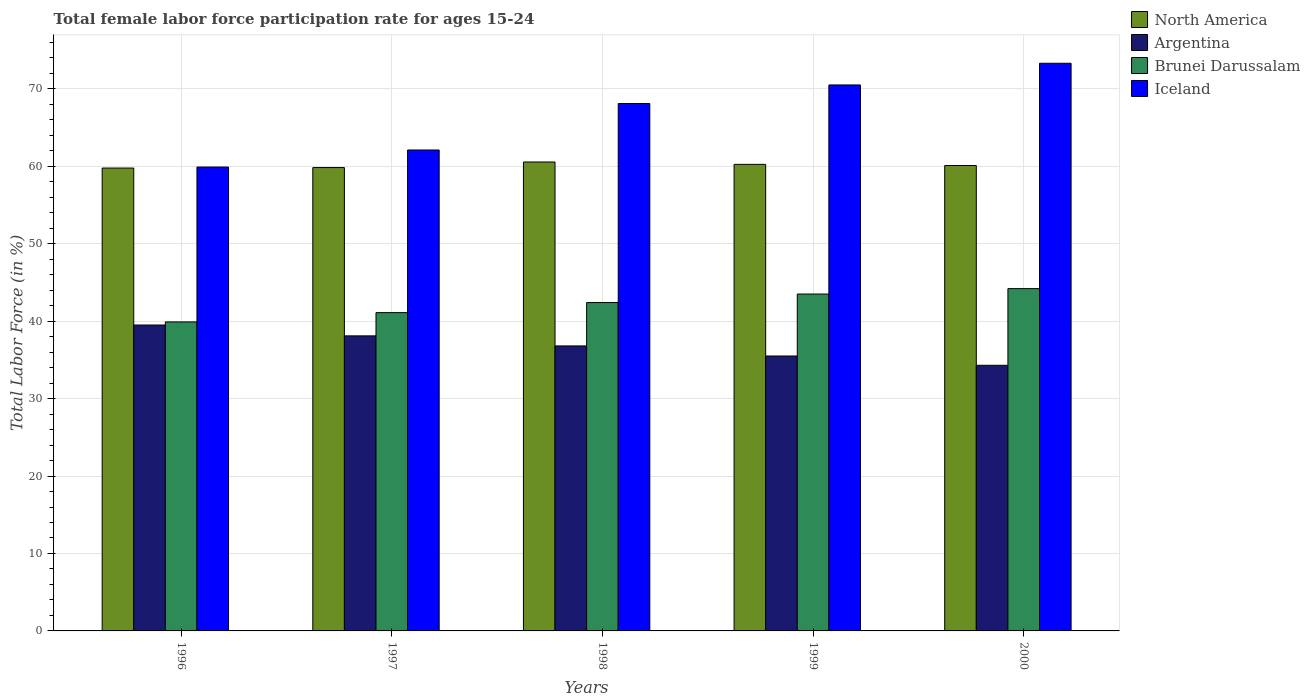How many different coloured bars are there?
Give a very brief answer. 4. How many groups of bars are there?
Make the answer very short. 5. Are the number of bars per tick equal to the number of legend labels?
Your response must be concise. Yes. Are the number of bars on each tick of the X-axis equal?
Your response must be concise. Yes. What is the label of the 2nd group of bars from the left?
Offer a terse response. 1997. In how many cases, is the number of bars for a given year not equal to the number of legend labels?
Offer a terse response. 0. What is the female labor force participation rate in Iceland in 1999?
Give a very brief answer. 70.5. Across all years, what is the maximum female labor force participation rate in Iceland?
Keep it short and to the point. 73.3. Across all years, what is the minimum female labor force participation rate in Iceland?
Make the answer very short. 59.9. In which year was the female labor force participation rate in Brunei Darussalam minimum?
Offer a very short reply. 1996. What is the total female labor force participation rate in North America in the graph?
Give a very brief answer. 300.49. What is the difference between the female labor force participation rate in Iceland in 1997 and that in 1999?
Ensure brevity in your answer.  -8.4. What is the difference between the female labor force participation rate in North America in 1998 and the female labor force participation rate in Argentina in 1996?
Keep it short and to the point. 21.05. What is the average female labor force participation rate in North America per year?
Your response must be concise. 60.1. In the year 2000, what is the difference between the female labor force participation rate in Brunei Darussalam and female labor force participation rate in Argentina?
Offer a very short reply. 9.9. What is the ratio of the female labor force participation rate in Argentina in 1996 to that in 1999?
Provide a short and direct response. 1.11. What is the difference between the highest and the second highest female labor force participation rate in Argentina?
Offer a very short reply. 1.4. What is the difference between the highest and the lowest female labor force participation rate in Brunei Darussalam?
Keep it short and to the point. 4.3. Is the sum of the female labor force participation rate in North America in 1996 and 1998 greater than the maximum female labor force participation rate in Iceland across all years?
Give a very brief answer. Yes. Is it the case that in every year, the sum of the female labor force participation rate in North America and female labor force participation rate in Iceland is greater than the sum of female labor force participation rate in Brunei Darussalam and female labor force participation rate in Argentina?
Provide a succinct answer. Yes. What does the 1st bar from the right in 1999 represents?
Make the answer very short. Iceland. Does the graph contain any zero values?
Your answer should be very brief. No. Where does the legend appear in the graph?
Ensure brevity in your answer.  Top right. What is the title of the graph?
Provide a succinct answer. Total female labor force participation rate for ages 15-24. What is the label or title of the X-axis?
Your answer should be compact. Years. What is the label or title of the Y-axis?
Ensure brevity in your answer.  Total Labor Force (in %). What is the Total Labor Force (in %) in North America in 1996?
Your answer should be compact. 59.77. What is the Total Labor Force (in %) of Argentina in 1996?
Your answer should be very brief. 39.5. What is the Total Labor Force (in %) in Brunei Darussalam in 1996?
Make the answer very short. 39.9. What is the Total Labor Force (in %) in Iceland in 1996?
Ensure brevity in your answer.  59.9. What is the Total Labor Force (in %) in North America in 1997?
Your response must be concise. 59.83. What is the Total Labor Force (in %) of Argentina in 1997?
Offer a terse response. 38.1. What is the Total Labor Force (in %) of Brunei Darussalam in 1997?
Make the answer very short. 41.1. What is the Total Labor Force (in %) of Iceland in 1997?
Your answer should be very brief. 62.1. What is the Total Labor Force (in %) of North America in 1998?
Give a very brief answer. 60.55. What is the Total Labor Force (in %) in Argentina in 1998?
Keep it short and to the point. 36.8. What is the Total Labor Force (in %) of Brunei Darussalam in 1998?
Provide a short and direct response. 42.4. What is the Total Labor Force (in %) of Iceland in 1998?
Provide a succinct answer. 68.1. What is the Total Labor Force (in %) in North America in 1999?
Offer a very short reply. 60.24. What is the Total Labor Force (in %) of Argentina in 1999?
Ensure brevity in your answer.  35.5. What is the Total Labor Force (in %) in Brunei Darussalam in 1999?
Your answer should be very brief. 43.5. What is the Total Labor Force (in %) in Iceland in 1999?
Provide a short and direct response. 70.5. What is the Total Labor Force (in %) in North America in 2000?
Provide a succinct answer. 60.1. What is the Total Labor Force (in %) in Argentina in 2000?
Give a very brief answer. 34.3. What is the Total Labor Force (in %) in Brunei Darussalam in 2000?
Offer a very short reply. 44.2. What is the Total Labor Force (in %) of Iceland in 2000?
Your answer should be compact. 73.3. Across all years, what is the maximum Total Labor Force (in %) of North America?
Keep it short and to the point. 60.55. Across all years, what is the maximum Total Labor Force (in %) of Argentina?
Provide a short and direct response. 39.5. Across all years, what is the maximum Total Labor Force (in %) of Brunei Darussalam?
Your response must be concise. 44.2. Across all years, what is the maximum Total Labor Force (in %) of Iceland?
Give a very brief answer. 73.3. Across all years, what is the minimum Total Labor Force (in %) in North America?
Keep it short and to the point. 59.77. Across all years, what is the minimum Total Labor Force (in %) in Argentina?
Offer a terse response. 34.3. Across all years, what is the minimum Total Labor Force (in %) of Brunei Darussalam?
Your answer should be compact. 39.9. Across all years, what is the minimum Total Labor Force (in %) of Iceland?
Your answer should be compact. 59.9. What is the total Total Labor Force (in %) of North America in the graph?
Offer a very short reply. 300.49. What is the total Total Labor Force (in %) of Argentina in the graph?
Your response must be concise. 184.2. What is the total Total Labor Force (in %) of Brunei Darussalam in the graph?
Offer a terse response. 211.1. What is the total Total Labor Force (in %) of Iceland in the graph?
Make the answer very short. 333.9. What is the difference between the Total Labor Force (in %) of North America in 1996 and that in 1997?
Provide a succinct answer. -0.06. What is the difference between the Total Labor Force (in %) in Argentina in 1996 and that in 1997?
Your response must be concise. 1.4. What is the difference between the Total Labor Force (in %) in Brunei Darussalam in 1996 and that in 1997?
Your answer should be compact. -1.2. What is the difference between the Total Labor Force (in %) of Iceland in 1996 and that in 1997?
Your answer should be very brief. -2.2. What is the difference between the Total Labor Force (in %) of North America in 1996 and that in 1998?
Provide a short and direct response. -0.78. What is the difference between the Total Labor Force (in %) of Brunei Darussalam in 1996 and that in 1998?
Your answer should be compact. -2.5. What is the difference between the Total Labor Force (in %) of Iceland in 1996 and that in 1998?
Your answer should be compact. -8.2. What is the difference between the Total Labor Force (in %) in North America in 1996 and that in 1999?
Keep it short and to the point. -0.48. What is the difference between the Total Labor Force (in %) in Argentina in 1996 and that in 1999?
Your answer should be compact. 4. What is the difference between the Total Labor Force (in %) in Brunei Darussalam in 1996 and that in 1999?
Your answer should be compact. -3.6. What is the difference between the Total Labor Force (in %) of North America in 1996 and that in 2000?
Provide a succinct answer. -0.33. What is the difference between the Total Labor Force (in %) of Argentina in 1996 and that in 2000?
Provide a short and direct response. 5.2. What is the difference between the Total Labor Force (in %) of Iceland in 1996 and that in 2000?
Offer a very short reply. -13.4. What is the difference between the Total Labor Force (in %) of North America in 1997 and that in 1998?
Provide a succinct answer. -0.72. What is the difference between the Total Labor Force (in %) of Argentina in 1997 and that in 1998?
Your response must be concise. 1.3. What is the difference between the Total Labor Force (in %) in North America in 1997 and that in 1999?
Your answer should be very brief. -0.41. What is the difference between the Total Labor Force (in %) of Brunei Darussalam in 1997 and that in 1999?
Your response must be concise. -2.4. What is the difference between the Total Labor Force (in %) in Iceland in 1997 and that in 1999?
Make the answer very short. -8.4. What is the difference between the Total Labor Force (in %) of North America in 1997 and that in 2000?
Provide a short and direct response. -0.26. What is the difference between the Total Labor Force (in %) of North America in 1998 and that in 1999?
Your answer should be very brief. 0.31. What is the difference between the Total Labor Force (in %) of Iceland in 1998 and that in 1999?
Your answer should be compact. -2.4. What is the difference between the Total Labor Force (in %) in North America in 1998 and that in 2000?
Offer a terse response. 0.45. What is the difference between the Total Labor Force (in %) in Argentina in 1998 and that in 2000?
Keep it short and to the point. 2.5. What is the difference between the Total Labor Force (in %) in Iceland in 1998 and that in 2000?
Give a very brief answer. -5.2. What is the difference between the Total Labor Force (in %) in North America in 1999 and that in 2000?
Provide a succinct answer. 0.15. What is the difference between the Total Labor Force (in %) in Brunei Darussalam in 1999 and that in 2000?
Make the answer very short. -0.7. What is the difference between the Total Labor Force (in %) in Iceland in 1999 and that in 2000?
Keep it short and to the point. -2.8. What is the difference between the Total Labor Force (in %) in North America in 1996 and the Total Labor Force (in %) in Argentina in 1997?
Your answer should be compact. 21.67. What is the difference between the Total Labor Force (in %) of North America in 1996 and the Total Labor Force (in %) of Brunei Darussalam in 1997?
Ensure brevity in your answer.  18.67. What is the difference between the Total Labor Force (in %) of North America in 1996 and the Total Labor Force (in %) of Iceland in 1997?
Your answer should be very brief. -2.33. What is the difference between the Total Labor Force (in %) of Argentina in 1996 and the Total Labor Force (in %) of Brunei Darussalam in 1997?
Ensure brevity in your answer.  -1.6. What is the difference between the Total Labor Force (in %) in Argentina in 1996 and the Total Labor Force (in %) in Iceland in 1997?
Give a very brief answer. -22.6. What is the difference between the Total Labor Force (in %) in Brunei Darussalam in 1996 and the Total Labor Force (in %) in Iceland in 1997?
Provide a short and direct response. -22.2. What is the difference between the Total Labor Force (in %) of North America in 1996 and the Total Labor Force (in %) of Argentina in 1998?
Offer a very short reply. 22.97. What is the difference between the Total Labor Force (in %) in North America in 1996 and the Total Labor Force (in %) in Brunei Darussalam in 1998?
Keep it short and to the point. 17.37. What is the difference between the Total Labor Force (in %) in North America in 1996 and the Total Labor Force (in %) in Iceland in 1998?
Ensure brevity in your answer.  -8.33. What is the difference between the Total Labor Force (in %) in Argentina in 1996 and the Total Labor Force (in %) in Iceland in 1998?
Provide a succinct answer. -28.6. What is the difference between the Total Labor Force (in %) in Brunei Darussalam in 1996 and the Total Labor Force (in %) in Iceland in 1998?
Your response must be concise. -28.2. What is the difference between the Total Labor Force (in %) in North America in 1996 and the Total Labor Force (in %) in Argentina in 1999?
Your response must be concise. 24.27. What is the difference between the Total Labor Force (in %) in North America in 1996 and the Total Labor Force (in %) in Brunei Darussalam in 1999?
Offer a terse response. 16.27. What is the difference between the Total Labor Force (in %) of North America in 1996 and the Total Labor Force (in %) of Iceland in 1999?
Your response must be concise. -10.73. What is the difference between the Total Labor Force (in %) of Argentina in 1996 and the Total Labor Force (in %) of Brunei Darussalam in 1999?
Offer a terse response. -4. What is the difference between the Total Labor Force (in %) in Argentina in 1996 and the Total Labor Force (in %) in Iceland in 1999?
Keep it short and to the point. -31. What is the difference between the Total Labor Force (in %) of Brunei Darussalam in 1996 and the Total Labor Force (in %) of Iceland in 1999?
Offer a terse response. -30.6. What is the difference between the Total Labor Force (in %) of North America in 1996 and the Total Labor Force (in %) of Argentina in 2000?
Offer a terse response. 25.47. What is the difference between the Total Labor Force (in %) in North America in 1996 and the Total Labor Force (in %) in Brunei Darussalam in 2000?
Your answer should be compact. 15.57. What is the difference between the Total Labor Force (in %) of North America in 1996 and the Total Labor Force (in %) of Iceland in 2000?
Offer a very short reply. -13.53. What is the difference between the Total Labor Force (in %) of Argentina in 1996 and the Total Labor Force (in %) of Brunei Darussalam in 2000?
Ensure brevity in your answer.  -4.7. What is the difference between the Total Labor Force (in %) in Argentina in 1996 and the Total Labor Force (in %) in Iceland in 2000?
Give a very brief answer. -33.8. What is the difference between the Total Labor Force (in %) of Brunei Darussalam in 1996 and the Total Labor Force (in %) of Iceland in 2000?
Provide a succinct answer. -33.4. What is the difference between the Total Labor Force (in %) of North America in 1997 and the Total Labor Force (in %) of Argentina in 1998?
Give a very brief answer. 23.03. What is the difference between the Total Labor Force (in %) in North America in 1997 and the Total Labor Force (in %) in Brunei Darussalam in 1998?
Make the answer very short. 17.43. What is the difference between the Total Labor Force (in %) in North America in 1997 and the Total Labor Force (in %) in Iceland in 1998?
Your answer should be compact. -8.27. What is the difference between the Total Labor Force (in %) of Brunei Darussalam in 1997 and the Total Labor Force (in %) of Iceland in 1998?
Offer a terse response. -27. What is the difference between the Total Labor Force (in %) in North America in 1997 and the Total Labor Force (in %) in Argentina in 1999?
Keep it short and to the point. 24.33. What is the difference between the Total Labor Force (in %) of North America in 1997 and the Total Labor Force (in %) of Brunei Darussalam in 1999?
Provide a succinct answer. 16.33. What is the difference between the Total Labor Force (in %) of North America in 1997 and the Total Labor Force (in %) of Iceland in 1999?
Offer a very short reply. -10.67. What is the difference between the Total Labor Force (in %) in Argentina in 1997 and the Total Labor Force (in %) in Iceland in 1999?
Keep it short and to the point. -32.4. What is the difference between the Total Labor Force (in %) of Brunei Darussalam in 1997 and the Total Labor Force (in %) of Iceland in 1999?
Provide a succinct answer. -29.4. What is the difference between the Total Labor Force (in %) in North America in 1997 and the Total Labor Force (in %) in Argentina in 2000?
Give a very brief answer. 25.53. What is the difference between the Total Labor Force (in %) of North America in 1997 and the Total Labor Force (in %) of Brunei Darussalam in 2000?
Keep it short and to the point. 15.63. What is the difference between the Total Labor Force (in %) of North America in 1997 and the Total Labor Force (in %) of Iceland in 2000?
Provide a succinct answer. -13.47. What is the difference between the Total Labor Force (in %) in Argentina in 1997 and the Total Labor Force (in %) in Brunei Darussalam in 2000?
Offer a terse response. -6.1. What is the difference between the Total Labor Force (in %) of Argentina in 1997 and the Total Labor Force (in %) of Iceland in 2000?
Provide a short and direct response. -35.2. What is the difference between the Total Labor Force (in %) of Brunei Darussalam in 1997 and the Total Labor Force (in %) of Iceland in 2000?
Keep it short and to the point. -32.2. What is the difference between the Total Labor Force (in %) of North America in 1998 and the Total Labor Force (in %) of Argentina in 1999?
Offer a very short reply. 25.05. What is the difference between the Total Labor Force (in %) of North America in 1998 and the Total Labor Force (in %) of Brunei Darussalam in 1999?
Make the answer very short. 17.05. What is the difference between the Total Labor Force (in %) of North America in 1998 and the Total Labor Force (in %) of Iceland in 1999?
Provide a succinct answer. -9.95. What is the difference between the Total Labor Force (in %) in Argentina in 1998 and the Total Labor Force (in %) in Iceland in 1999?
Your answer should be very brief. -33.7. What is the difference between the Total Labor Force (in %) in Brunei Darussalam in 1998 and the Total Labor Force (in %) in Iceland in 1999?
Keep it short and to the point. -28.1. What is the difference between the Total Labor Force (in %) in North America in 1998 and the Total Labor Force (in %) in Argentina in 2000?
Your answer should be compact. 26.25. What is the difference between the Total Labor Force (in %) of North America in 1998 and the Total Labor Force (in %) of Brunei Darussalam in 2000?
Make the answer very short. 16.35. What is the difference between the Total Labor Force (in %) of North America in 1998 and the Total Labor Force (in %) of Iceland in 2000?
Your answer should be very brief. -12.75. What is the difference between the Total Labor Force (in %) of Argentina in 1998 and the Total Labor Force (in %) of Iceland in 2000?
Ensure brevity in your answer.  -36.5. What is the difference between the Total Labor Force (in %) of Brunei Darussalam in 1998 and the Total Labor Force (in %) of Iceland in 2000?
Provide a short and direct response. -30.9. What is the difference between the Total Labor Force (in %) of North America in 1999 and the Total Labor Force (in %) of Argentina in 2000?
Ensure brevity in your answer.  25.94. What is the difference between the Total Labor Force (in %) of North America in 1999 and the Total Labor Force (in %) of Brunei Darussalam in 2000?
Offer a terse response. 16.04. What is the difference between the Total Labor Force (in %) in North America in 1999 and the Total Labor Force (in %) in Iceland in 2000?
Provide a short and direct response. -13.06. What is the difference between the Total Labor Force (in %) of Argentina in 1999 and the Total Labor Force (in %) of Brunei Darussalam in 2000?
Ensure brevity in your answer.  -8.7. What is the difference between the Total Labor Force (in %) in Argentina in 1999 and the Total Labor Force (in %) in Iceland in 2000?
Offer a very short reply. -37.8. What is the difference between the Total Labor Force (in %) of Brunei Darussalam in 1999 and the Total Labor Force (in %) of Iceland in 2000?
Provide a succinct answer. -29.8. What is the average Total Labor Force (in %) in North America per year?
Ensure brevity in your answer.  60.1. What is the average Total Labor Force (in %) of Argentina per year?
Your answer should be compact. 36.84. What is the average Total Labor Force (in %) in Brunei Darussalam per year?
Your response must be concise. 42.22. What is the average Total Labor Force (in %) of Iceland per year?
Your answer should be very brief. 66.78. In the year 1996, what is the difference between the Total Labor Force (in %) in North America and Total Labor Force (in %) in Argentina?
Give a very brief answer. 20.27. In the year 1996, what is the difference between the Total Labor Force (in %) of North America and Total Labor Force (in %) of Brunei Darussalam?
Your answer should be compact. 19.87. In the year 1996, what is the difference between the Total Labor Force (in %) of North America and Total Labor Force (in %) of Iceland?
Provide a succinct answer. -0.13. In the year 1996, what is the difference between the Total Labor Force (in %) in Argentina and Total Labor Force (in %) in Brunei Darussalam?
Offer a very short reply. -0.4. In the year 1996, what is the difference between the Total Labor Force (in %) of Argentina and Total Labor Force (in %) of Iceland?
Your response must be concise. -20.4. In the year 1996, what is the difference between the Total Labor Force (in %) of Brunei Darussalam and Total Labor Force (in %) of Iceland?
Keep it short and to the point. -20. In the year 1997, what is the difference between the Total Labor Force (in %) in North America and Total Labor Force (in %) in Argentina?
Give a very brief answer. 21.73. In the year 1997, what is the difference between the Total Labor Force (in %) in North America and Total Labor Force (in %) in Brunei Darussalam?
Provide a succinct answer. 18.73. In the year 1997, what is the difference between the Total Labor Force (in %) in North America and Total Labor Force (in %) in Iceland?
Your answer should be very brief. -2.27. In the year 1997, what is the difference between the Total Labor Force (in %) of Argentina and Total Labor Force (in %) of Brunei Darussalam?
Offer a very short reply. -3. In the year 1997, what is the difference between the Total Labor Force (in %) in Brunei Darussalam and Total Labor Force (in %) in Iceland?
Your response must be concise. -21. In the year 1998, what is the difference between the Total Labor Force (in %) in North America and Total Labor Force (in %) in Argentina?
Offer a terse response. 23.75. In the year 1998, what is the difference between the Total Labor Force (in %) in North America and Total Labor Force (in %) in Brunei Darussalam?
Make the answer very short. 18.15. In the year 1998, what is the difference between the Total Labor Force (in %) in North America and Total Labor Force (in %) in Iceland?
Ensure brevity in your answer.  -7.55. In the year 1998, what is the difference between the Total Labor Force (in %) in Argentina and Total Labor Force (in %) in Iceland?
Give a very brief answer. -31.3. In the year 1998, what is the difference between the Total Labor Force (in %) in Brunei Darussalam and Total Labor Force (in %) in Iceland?
Ensure brevity in your answer.  -25.7. In the year 1999, what is the difference between the Total Labor Force (in %) of North America and Total Labor Force (in %) of Argentina?
Provide a short and direct response. 24.74. In the year 1999, what is the difference between the Total Labor Force (in %) of North America and Total Labor Force (in %) of Brunei Darussalam?
Your answer should be very brief. 16.74. In the year 1999, what is the difference between the Total Labor Force (in %) in North America and Total Labor Force (in %) in Iceland?
Keep it short and to the point. -10.26. In the year 1999, what is the difference between the Total Labor Force (in %) in Argentina and Total Labor Force (in %) in Iceland?
Your answer should be compact. -35. In the year 1999, what is the difference between the Total Labor Force (in %) in Brunei Darussalam and Total Labor Force (in %) in Iceland?
Offer a terse response. -27. In the year 2000, what is the difference between the Total Labor Force (in %) of North America and Total Labor Force (in %) of Argentina?
Your answer should be compact. 25.8. In the year 2000, what is the difference between the Total Labor Force (in %) in North America and Total Labor Force (in %) in Brunei Darussalam?
Your response must be concise. 15.9. In the year 2000, what is the difference between the Total Labor Force (in %) in North America and Total Labor Force (in %) in Iceland?
Offer a terse response. -13.2. In the year 2000, what is the difference between the Total Labor Force (in %) of Argentina and Total Labor Force (in %) of Brunei Darussalam?
Offer a terse response. -9.9. In the year 2000, what is the difference between the Total Labor Force (in %) of Argentina and Total Labor Force (in %) of Iceland?
Your answer should be very brief. -39. In the year 2000, what is the difference between the Total Labor Force (in %) of Brunei Darussalam and Total Labor Force (in %) of Iceland?
Offer a terse response. -29.1. What is the ratio of the Total Labor Force (in %) of Argentina in 1996 to that in 1997?
Offer a terse response. 1.04. What is the ratio of the Total Labor Force (in %) in Brunei Darussalam in 1996 to that in 1997?
Provide a succinct answer. 0.97. What is the ratio of the Total Labor Force (in %) in Iceland in 1996 to that in 1997?
Make the answer very short. 0.96. What is the ratio of the Total Labor Force (in %) of North America in 1996 to that in 1998?
Your answer should be compact. 0.99. What is the ratio of the Total Labor Force (in %) in Argentina in 1996 to that in 1998?
Your answer should be very brief. 1.07. What is the ratio of the Total Labor Force (in %) in Brunei Darussalam in 1996 to that in 1998?
Keep it short and to the point. 0.94. What is the ratio of the Total Labor Force (in %) of Iceland in 1996 to that in 1998?
Offer a terse response. 0.88. What is the ratio of the Total Labor Force (in %) in North America in 1996 to that in 1999?
Your answer should be compact. 0.99. What is the ratio of the Total Labor Force (in %) in Argentina in 1996 to that in 1999?
Provide a succinct answer. 1.11. What is the ratio of the Total Labor Force (in %) in Brunei Darussalam in 1996 to that in 1999?
Provide a succinct answer. 0.92. What is the ratio of the Total Labor Force (in %) in Iceland in 1996 to that in 1999?
Provide a short and direct response. 0.85. What is the ratio of the Total Labor Force (in %) in North America in 1996 to that in 2000?
Provide a short and direct response. 0.99. What is the ratio of the Total Labor Force (in %) of Argentina in 1996 to that in 2000?
Make the answer very short. 1.15. What is the ratio of the Total Labor Force (in %) in Brunei Darussalam in 1996 to that in 2000?
Give a very brief answer. 0.9. What is the ratio of the Total Labor Force (in %) in Iceland in 1996 to that in 2000?
Your response must be concise. 0.82. What is the ratio of the Total Labor Force (in %) in North America in 1997 to that in 1998?
Keep it short and to the point. 0.99. What is the ratio of the Total Labor Force (in %) of Argentina in 1997 to that in 1998?
Give a very brief answer. 1.04. What is the ratio of the Total Labor Force (in %) in Brunei Darussalam in 1997 to that in 1998?
Offer a very short reply. 0.97. What is the ratio of the Total Labor Force (in %) in Iceland in 1997 to that in 1998?
Your answer should be very brief. 0.91. What is the ratio of the Total Labor Force (in %) of North America in 1997 to that in 1999?
Make the answer very short. 0.99. What is the ratio of the Total Labor Force (in %) of Argentina in 1997 to that in 1999?
Your answer should be very brief. 1.07. What is the ratio of the Total Labor Force (in %) in Brunei Darussalam in 1997 to that in 1999?
Provide a short and direct response. 0.94. What is the ratio of the Total Labor Force (in %) in Iceland in 1997 to that in 1999?
Provide a short and direct response. 0.88. What is the ratio of the Total Labor Force (in %) in North America in 1997 to that in 2000?
Provide a short and direct response. 1. What is the ratio of the Total Labor Force (in %) of Argentina in 1997 to that in 2000?
Ensure brevity in your answer.  1.11. What is the ratio of the Total Labor Force (in %) of Brunei Darussalam in 1997 to that in 2000?
Your answer should be compact. 0.93. What is the ratio of the Total Labor Force (in %) of Iceland in 1997 to that in 2000?
Offer a very short reply. 0.85. What is the ratio of the Total Labor Force (in %) of North America in 1998 to that in 1999?
Keep it short and to the point. 1.01. What is the ratio of the Total Labor Force (in %) in Argentina in 1998 to that in 1999?
Offer a very short reply. 1.04. What is the ratio of the Total Labor Force (in %) in Brunei Darussalam in 1998 to that in 1999?
Your answer should be very brief. 0.97. What is the ratio of the Total Labor Force (in %) in Iceland in 1998 to that in 1999?
Provide a short and direct response. 0.97. What is the ratio of the Total Labor Force (in %) in North America in 1998 to that in 2000?
Offer a terse response. 1.01. What is the ratio of the Total Labor Force (in %) of Argentina in 1998 to that in 2000?
Offer a terse response. 1.07. What is the ratio of the Total Labor Force (in %) of Brunei Darussalam in 1998 to that in 2000?
Your response must be concise. 0.96. What is the ratio of the Total Labor Force (in %) of Iceland in 1998 to that in 2000?
Your response must be concise. 0.93. What is the ratio of the Total Labor Force (in %) of Argentina in 1999 to that in 2000?
Keep it short and to the point. 1.03. What is the ratio of the Total Labor Force (in %) in Brunei Darussalam in 1999 to that in 2000?
Offer a very short reply. 0.98. What is the ratio of the Total Labor Force (in %) in Iceland in 1999 to that in 2000?
Your response must be concise. 0.96. What is the difference between the highest and the second highest Total Labor Force (in %) of North America?
Offer a terse response. 0.31. What is the difference between the highest and the second highest Total Labor Force (in %) in Brunei Darussalam?
Your answer should be very brief. 0.7. What is the difference between the highest and the lowest Total Labor Force (in %) of North America?
Make the answer very short. 0.78. What is the difference between the highest and the lowest Total Labor Force (in %) of Argentina?
Keep it short and to the point. 5.2. 